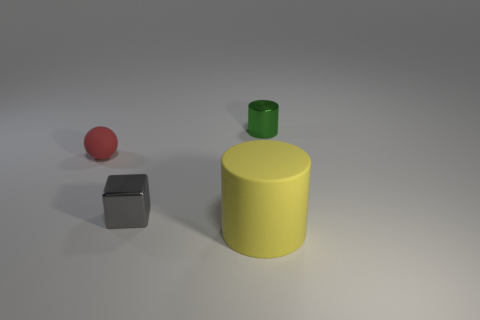What number of matte things are the same color as the metal block?
Your answer should be very brief. 0. How many big blue things are made of the same material as the cube?
Provide a short and direct response. 0. What number of things are either yellow cylinders or objects that are in front of the small red ball?
Give a very brief answer. 2. What color is the tiny metal thing on the left side of the cylinder that is on the left side of the small shiny thing that is to the right of the gray shiny block?
Offer a very short reply. Gray. There is a matte object in front of the small red object; what size is it?
Make the answer very short. Large. How many big objects are red things or gray cubes?
Your response must be concise. 0. There is a object that is on the right side of the gray cube and in front of the red sphere; what color is it?
Offer a terse response. Yellow. Are there any red objects that have the same shape as the tiny green thing?
Offer a terse response. No. What is the material of the large yellow cylinder?
Provide a short and direct response. Rubber. There is a metal cylinder; are there any metal blocks behind it?
Offer a very short reply. No. 